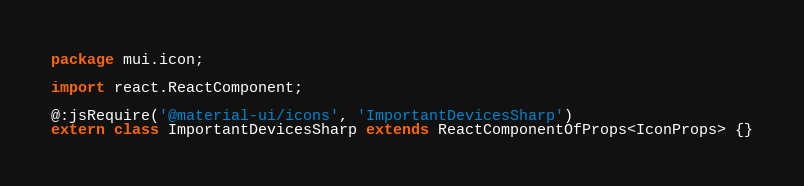<code> <loc_0><loc_0><loc_500><loc_500><_Haxe_>package mui.icon;

import react.ReactComponent;

@:jsRequire('@material-ui/icons', 'ImportantDevicesSharp')
extern class ImportantDevicesSharp extends ReactComponentOfProps<IconProps> {}
</code> 